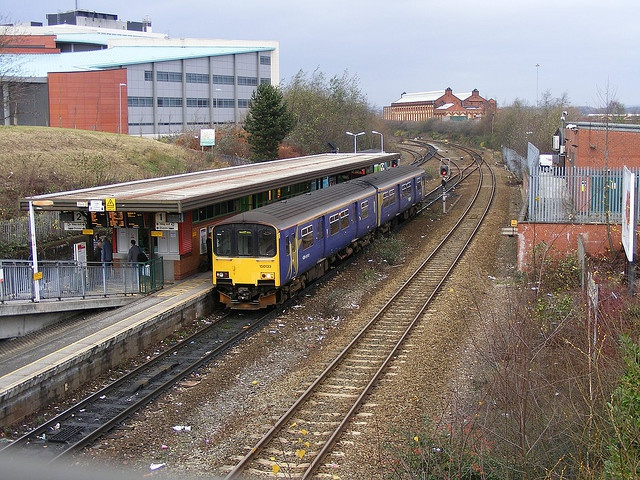Describe the objects in this image and their specific colors. I can see train in lightblue, black, gray, navy, and darkgray tones, people in lightblue, black, and gray tones, traffic light in lightblue, gray, black, and darkgray tones, people in lightblue, black, gray, and darkgray tones, and people in lightblue, black, gray, and darkblue tones in this image. 